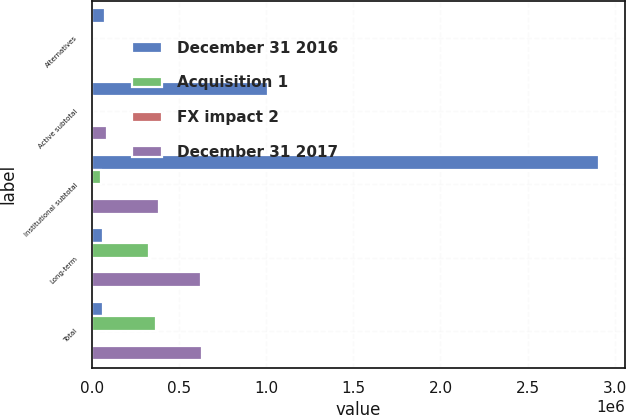<chart> <loc_0><loc_0><loc_500><loc_500><stacked_bar_chart><ecel><fcel>Alternatives<fcel>Active subtotal<fcel>Institutional subtotal<fcel>Long-term<fcel>Total<nl><fcel>December 31 2016<fcel>75615<fcel>1.00997e+06<fcel>2.91166e+06<fcel>65310.5<fcel>65310.5<nl><fcel>Acquisition 1<fcel>566<fcel>5922<fcel>55006<fcel>330240<fcel>367254<nl><fcel>FX impact 2<fcel>3264<fcel>3264<fcel>3264<fcel>3264<fcel>3264<nl><fcel>December 31 2017<fcel>2771<fcel>88155<fcel>387492<fcel>627867<fcel>628901<nl></chart> 